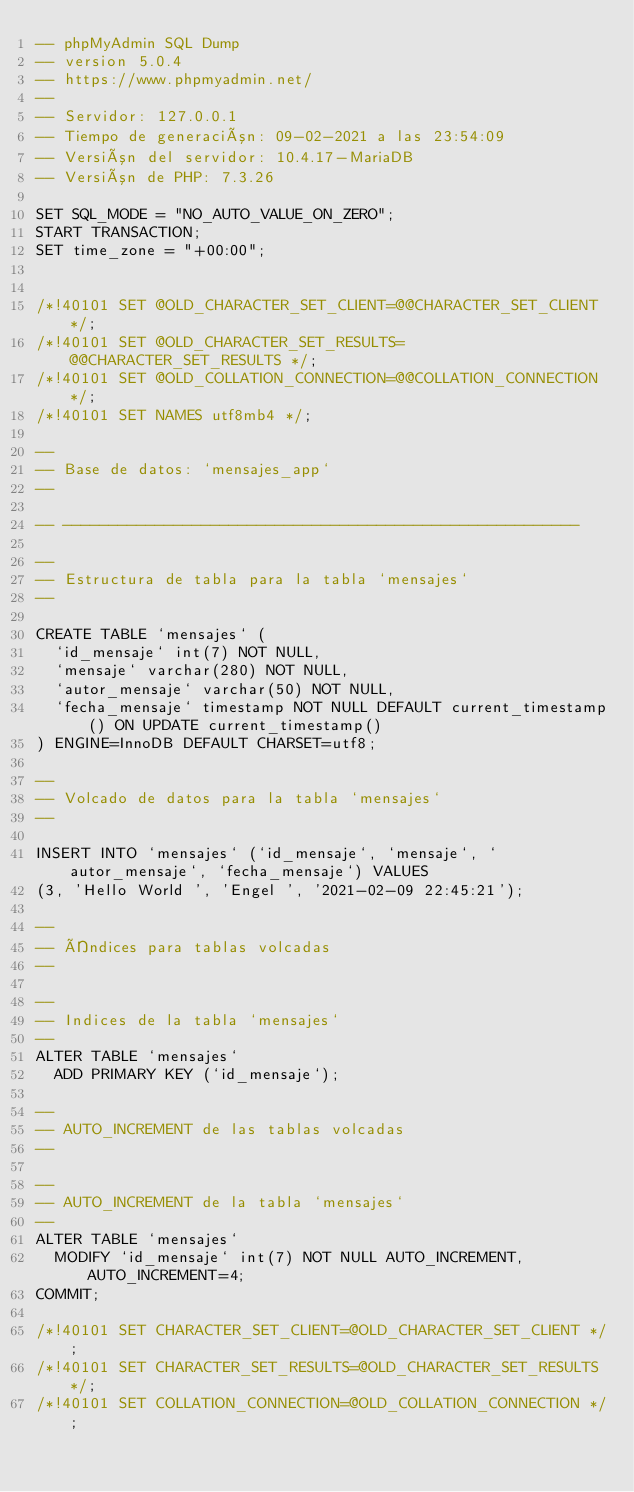Convert code to text. <code><loc_0><loc_0><loc_500><loc_500><_SQL_>-- phpMyAdmin SQL Dump
-- version 5.0.4
-- https://www.phpmyadmin.net/
--
-- Servidor: 127.0.0.1
-- Tiempo de generación: 09-02-2021 a las 23:54:09
-- Versión del servidor: 10.4.17-MariaDB
-- Versión de PHP: 7.3.26

SET SQL_MODE = "NO_AUTO_VALUE_ON_ZERO";
START TRANSACTION;
SET time_zone = "+00:00";


/*!40101 SET @OLD_CHARACTER_SET_CLIENT=@@CHARACTER_SET_CLIENT */;
/*!40101 SET @OLD_CHARACTER_SET_RESULTS=@@CHARACTER_SET_RESULTS */;
/*!40101 SET @OLD_COLLATION_CONNECTION=@@COLLATION_CONNECTION */;
/*!40101 SET NAMES utf8mb4 */;

--
-- Base de datos: `mensajes_app`
--

-- --------------------------------------------------------

--
-- Estructura de tabla para la tabla `mensajes`
--

CREATE TABLE `mensajes` (
  `id_mensaje` int(7) NOT NULL,
  `mensaje` varchar(280) NOT NULL,
  `autor_mensaje` varchar(50) NOT NULL,
  `fecha_mensaje` timestamp NOT NULL DEFAULT current_timestamp() ON UPDATE current_timestamp()
) ENGINE=InnoDB DEFAULT CHARSET=utf8;

--
-- Volcado de datos para la tabla `mensajes`
--

INSERT INTO `mensajes` (`id_mensaje`, `mensaje`, `autor_mensaje`, `fecha_mensaje`) VALUES
(3, 'Hello World ', 'Engel ', '2021-02-09 22:45:21');

--
-- Índices para tablas volcadas
--

--
-- Indices de la tabla `mensajes`
--
ALTER TABLE `mensajes`
  ADD PRIMARY KEY (`id_mensaje`);

--
-- AUTO_INCREMENT de las tablas volcadas
--

--
-- AUTO_INCREMENT de la tabla `mensajes`
--
ALTER TABLE `mensajes`
  MODIFY `id_mensaje` int(7) NOT NULL AUTO_INCREMENT, AUTO_INCREMENT=4;
COMMIT;

/*!40101 SET CHARACTER_SET_CLIENT=@OLD_CHARACTER_SET_CLIENT */;
/*!40101 SET CHARACTER_SET_RESULTS=@OLD_CHARACTER_SET_RESULTS */;
/*!40101 SET COLLATION_CONNECTION=@OLD_COLLATION_CONNECTION */;
</code> 